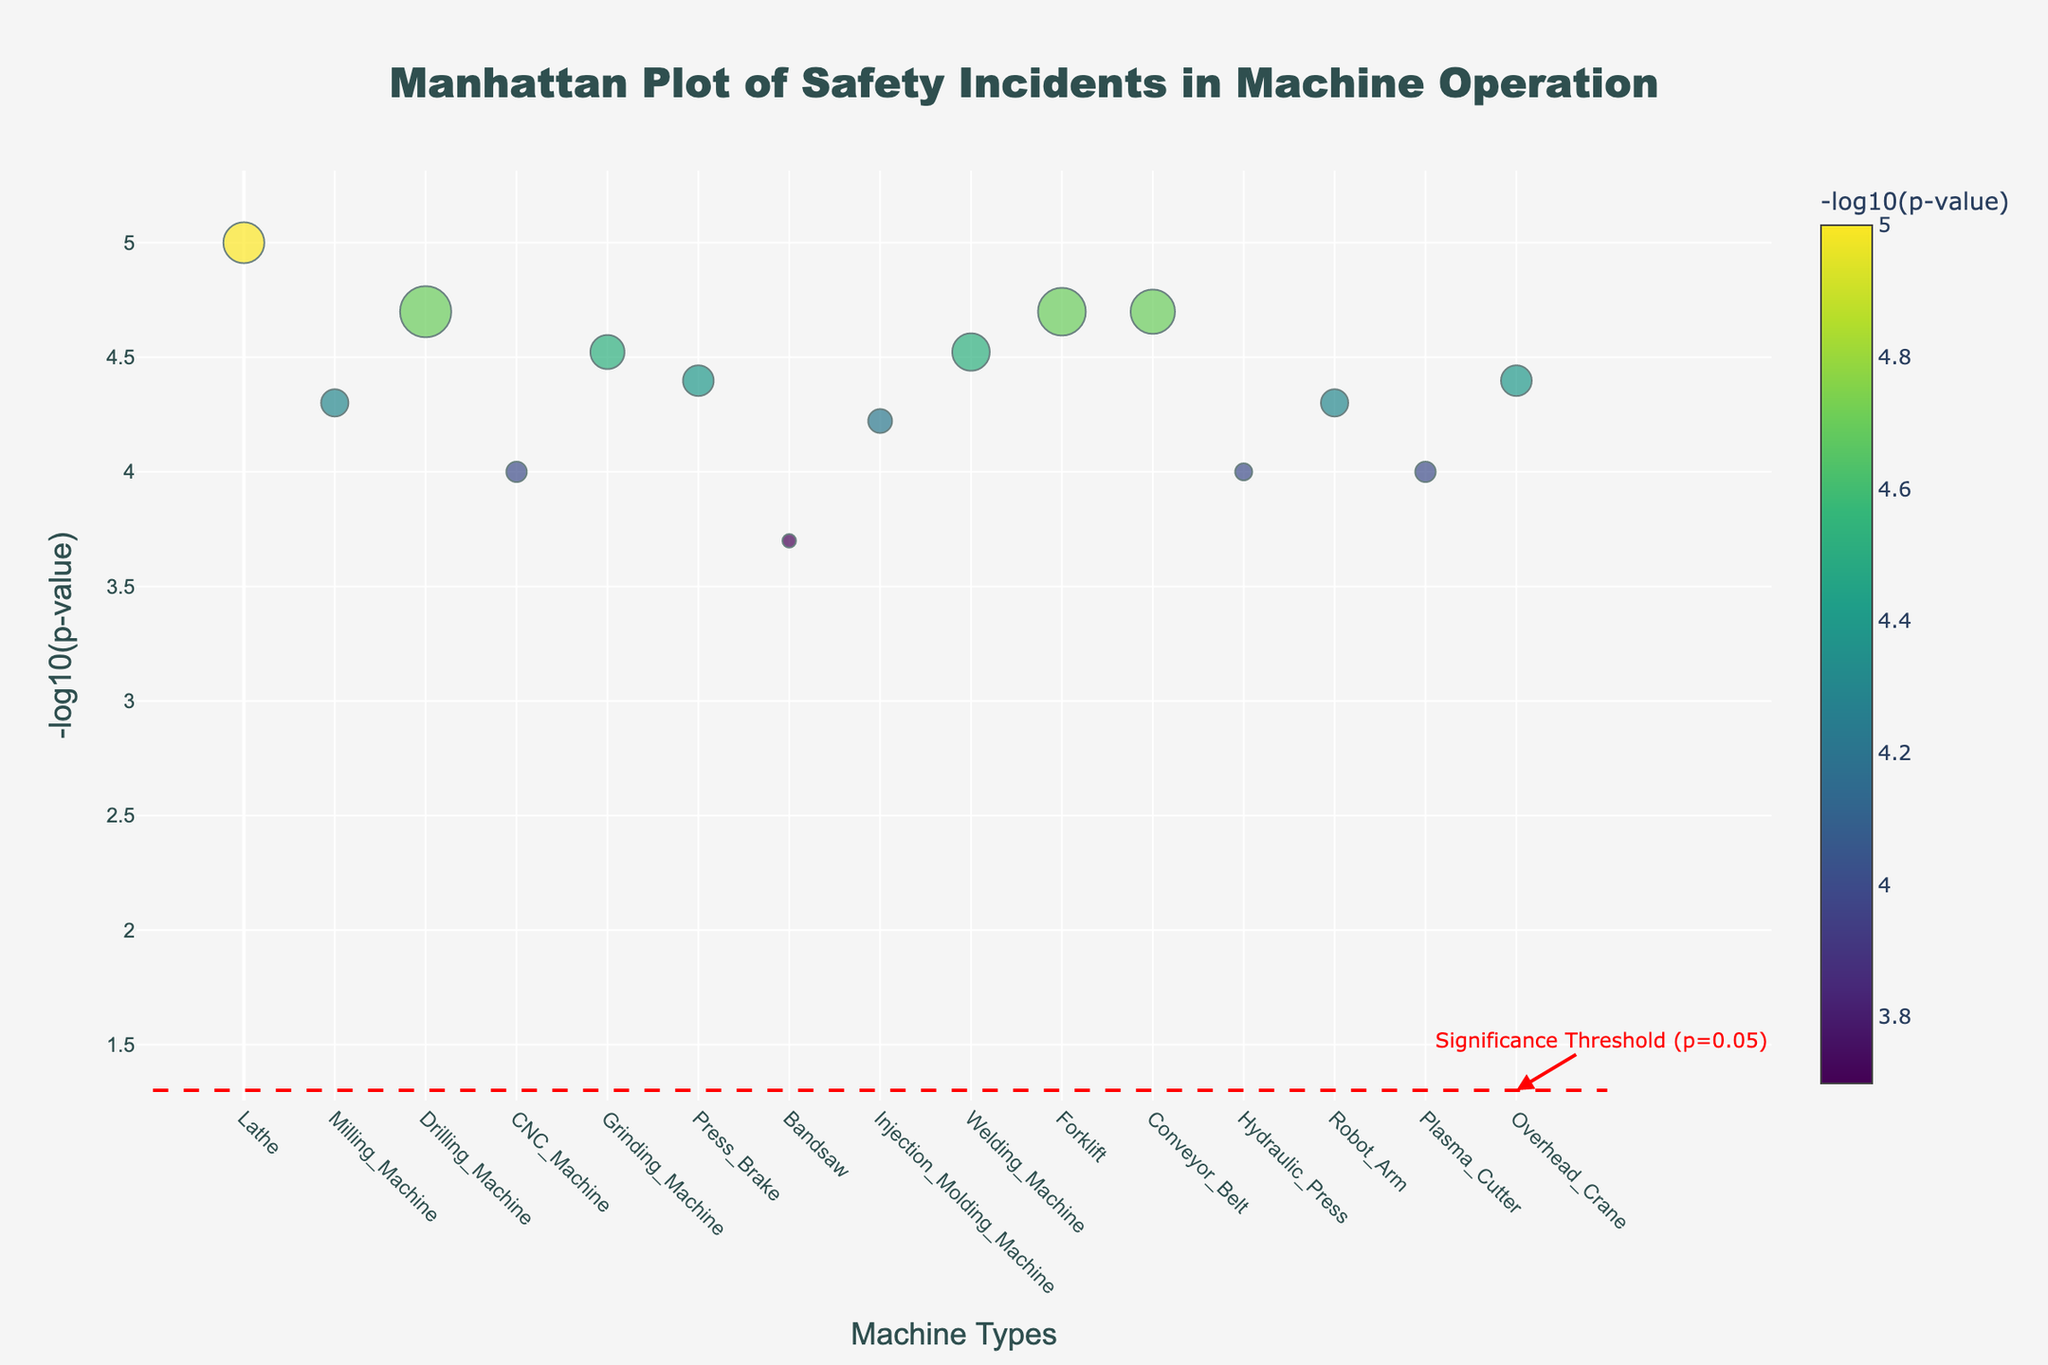What is the title of the Manhattan plot? The title is prominently displayed at the top of the figure. It reads "Manhattan Plot of Safety Incidents in Machine Operation".
Answer: Manhattan Plot of Safety Incidents in Machine Operation Which machine type has the highest -log10(p-value)? By examining the y-axis, we can see the highest point on the plot, which corresponds to the Lathe machine.
Answer: Lathe How many data points are represented in the plot? Each data point corresponds to a specific machine type. By counting the number of unique machine types along the x-axis, we find that there are 15 data points.
Answer: 15 What is the frequency of incidents for the machine type with the lowest -log10(p-value)? Looking at the lowest point on the y-axis of the plot, it corresponds to the Bandsaw machine. The hover information indicates that the frequency of incidents for the Bandsaw is 4.
Answer: 4 Which incident type has the highest frequency in the workshop environment? When looking at the hover text for each machine type in the workshop environment, the Milling Machine has the incident type of Crushing with a frequency of 8.
Answer: Crushing What is the significance threshold indicated on the plot? A dashed red line is drawn across the plot, and an annotation near the end indicates this line corresponds to a p-value of 0.05, or -log10(0.05).
Answer: p=0.05 Compare the -log10(p-value) of incidents in the Factory environment versus the Workshop environment. Which is higher? The hover text indicates that the Lathe in the Factory environment has a -log10(p-value) greater than the Milling Machine in the Workshop environment. Therefore, the Factory environment has a higher -log10(p-value).
Answer: Factory How does the frequency of incidents for the Drilling Machine compare to that of the Conveyor Belt? From the hover text, the Drilling Machine has a frequency of 15 incidents, while the Conveyor Belt has 13 incidents. Therefore, the Drilling Machine has a higher frequency of incidents.
Answer: Drilling Machine Which environment has incidents related to Falls and what is their p-value? By checking the hover text, we find that the Drilling Machine in the Construction Site has incidents related to Falls with a p-value of 0.00002.
Answer: Construction Site, 0.00002 What is the p-value for incidents relating to Electrical Shock in the Manufacturing Plant? The hover text for the CNC Machine in the Manufacturing Plant shows that incidents related to Electrical Shock have a p-value of 0.0001.
Answer: 0.0001 